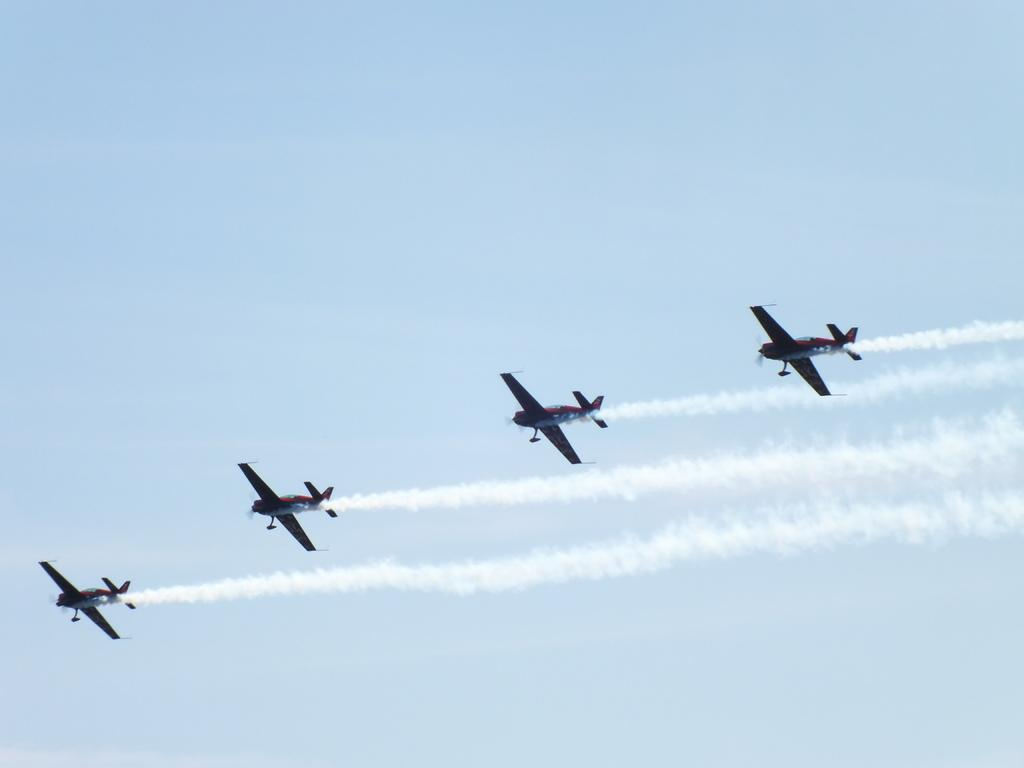How many airplanes are present in the image? There are four airplanes in the image. What are the airplanes doing in the image? The airplanes are flying in the air. What can be seen in the background of the image? There is a sky visible in the background of the image. What type of celery can be seen growing in the image? There is no celery present in the image; it features four airplanes flying in the sky. Is there a crook visible in the image? There is no crook present in the image; it features four airplanes flying in the sky. 